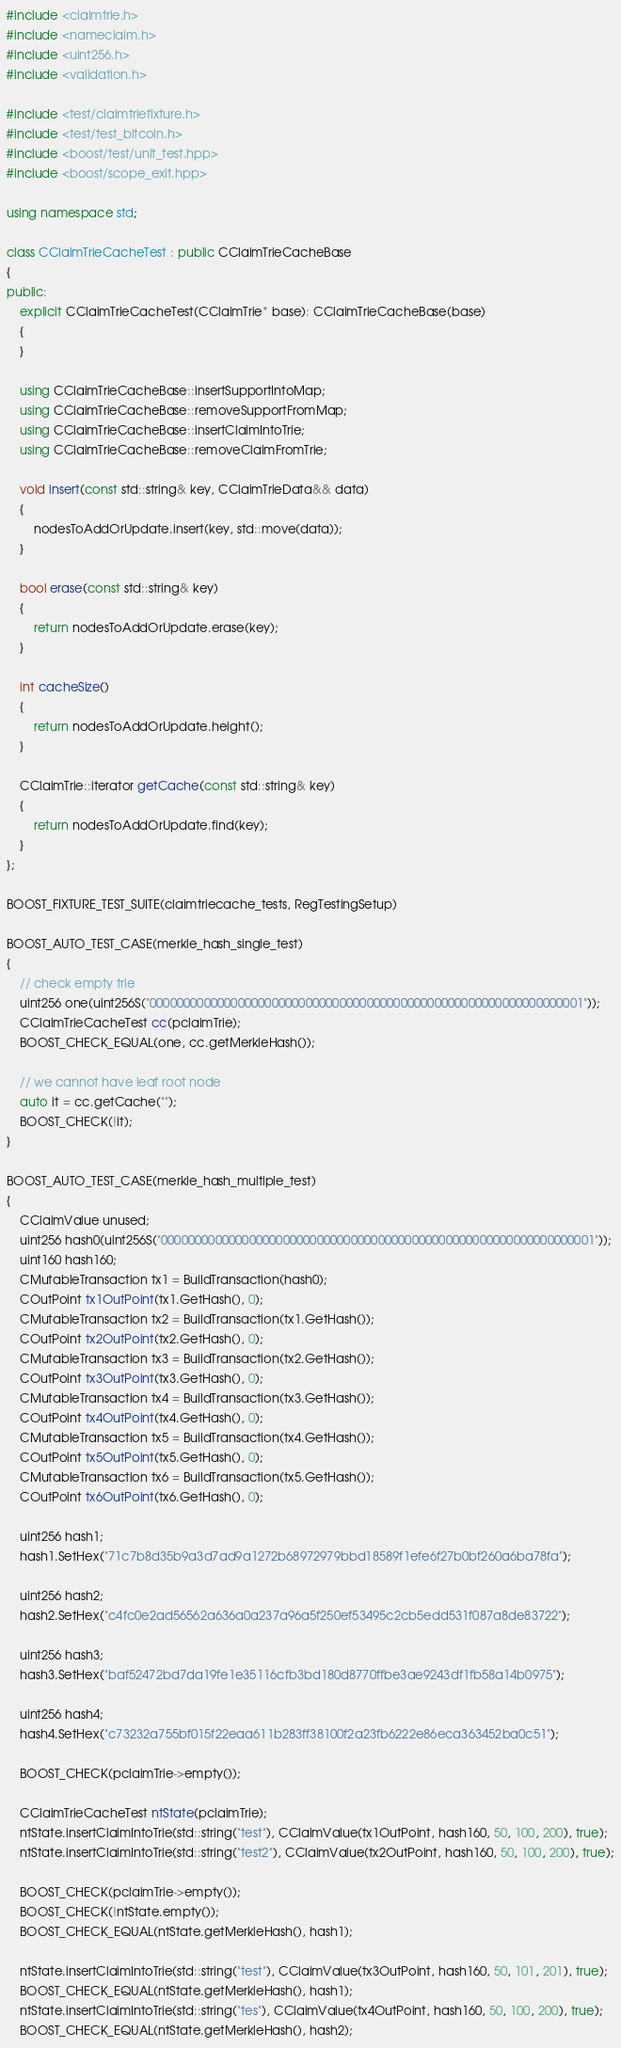Convert code to text. <code><loc_0><loc_0><loc_500><loc_500><_C++_>#include <claimtrie.h>
#include <nameclaim.h>
#include <uint256.h>
#include <validation.h>

#include <test/claimtriefixture.h>
#include <test/test_bitcoin.h>
#include <boost/test/unit_test.hpp>
#include <boost/scope_exit.hpp>

using namespace std;

class CClaimTrieCacheTest : public CClaimTrieCacheBase
{
public:
    explicit CClaimTrieCacheTest(CClaimTrie* base): CClaimTrieCacheBase(base)
    {
    }

    using CClaimTrieCacheBase::insertSupportIntoMap;
    using CClaimTrieCacheBase::removeSupportFromMap;
    using CClaimTrieCacheBase::insertClaimIntoTrie;
    using CClaimTrieCacheBase::removeClaimFromTrie;

    void insert(const std::string& key, CClaimTrieData&& data)
    {
        nodesToAddOrUpdate.insert(key, std::move(data));
    }

    bool erase(const std::string& key)
    {
        return nodesToAddOrUpdate.erase(key);
    }

    int cacheSize()
    {
        return nodesToAddOrUpdate.height();
    }

    CClaimTrie::iterator getCache(const std::string& key)
    {
        return nodesToAddOrUpdate.find(key);
    }
};

BOOST_FIXTURE_TEST_SUITE(claimtriecache_tests, RegTestingSetup)

BOOST_AUTO_TEST_CASE(merkle_hash_single_test)
{
    // check empty trie
    uint256 one(uint256S("0000000000000000000000000000000000000000000000000000000000000001"));
    CClaimTrieCacheTest cc(pclaimTrie);
    BOOST_CHECK_EQUAL(one, cc.getMerkleHash());

    // we cannot have leaf root node
    auto it = cc.getCache("");
    BOOST_CHECK(!it);
}

BOOST_AUTO_TEST_CASE(merkle_hash_multiple_test)
{
    CClaimValue unused;
    uint256 hash0(uint256S("0000000000000000000000000000000000000000000000000000000000000001"));
    uint160 hash160;
    CMutableTransaction tx1 = BuildTransaction(hash0);
    COutPoint tx1OutPoint(tx1.GetHash(), 0);
    CMutableTransaction tx2 = BuildTransaction(tx1.GetHash());
    COutPoint tx2OutPoint(tx2.GetHash(), 0);
    CMutableTransaction tx3 = BuildTransaction(tx2.GetHash());
    COutPoint tx3OutPoint(tx3.GetHash(), 0);
    CMutableTransaction tx4 = BuildTransaction(tx3.GetHash());
    COutPoint tx4OutPoint(tx4.GetHash(), 0);
    CMutableTransaction tx5 = BuildTransaction(tx4.GetHash());
    COutPoint tx5OutPoint(tx5.GetHash(), 0);
    CMutableTransaction tx6 = BuildTransaction(tx5.GetHash());
    COutPoint tx6OutPoint(tx6.GetHash(), 0);

    uint256 hash1;
    hash1.SetHex("71c7b8d35b9a3d7ad9a1272b68972979bbd18589f1efe6f27b0bf260a6ba78fa");

    uint256 hash2;
    hash2.SetHex("c4fc0e2ad56562a636a0a237a96a5f250ef53495c2cb5edd531f087a8de83722");

    uint256 hash3;
    hash3.SetHex("baf52472bd7da19fe1e35116cfb3bd180d8770ffbe3ae9243df1fb58a14b0975");

    uint256 hash4;
    hash4.SetHex("c73232a755bf015f22eaa611b283ff38100f2a23fb6222e86eca363452ba0c51");

    BOOST_CHECK(pclaimTrie->empty());

    CClaimTrieCacheTest ntState(pclaimTrie);
    ntState.insertClaimIntoTrie(std::string("test"), CClaimValue(tx1OutPoint, hash160, 50, 100, 200), true);
    ntState.insertClaimIntoTrie(std::string("test2"), CClaimValue(tx2OutPoint, hash160, 50, 100, 200), true);

    BOOST_CHECK(pclaimTrie->empty());
    BOOST_CHECK(!ntState.empty());
    BOOST_CHECK_EQUAL(ntState.getMerkleHash(), hash1);

    ntState.insertClaimIntoTrie(std::string("test"), CClaimValue(tx3OutPoint, hash160, 50, 101, 201), true);
    BOOST_CHECK_EQUAL(ntState.getMerkleHash(), hash1);
    ntState.insertClaimIntoTrie(std::string("tes"), CClaimValue(tx4OutPoint, hash160, 50, 100, 200), true);
    BOOST_CHECK_EQUAL(ntState.getMerkleHash(), hash2);</code> 